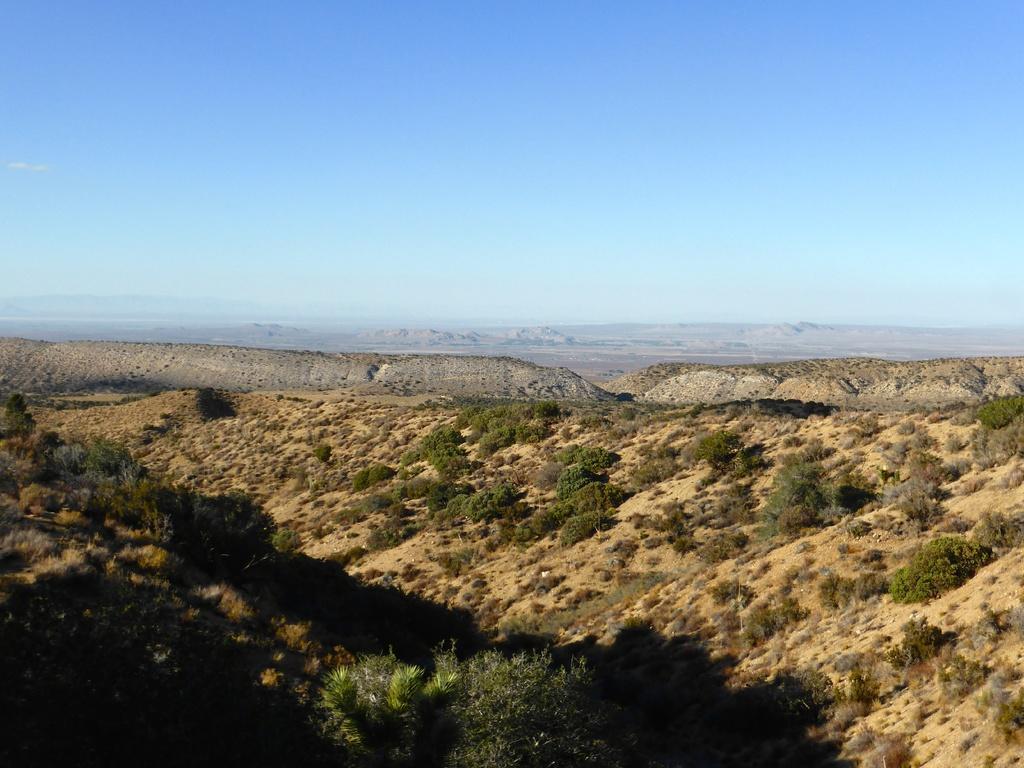Describe this image in one or two sentences. In this picture we can see plants, mountains and in the background we can see the sky. 